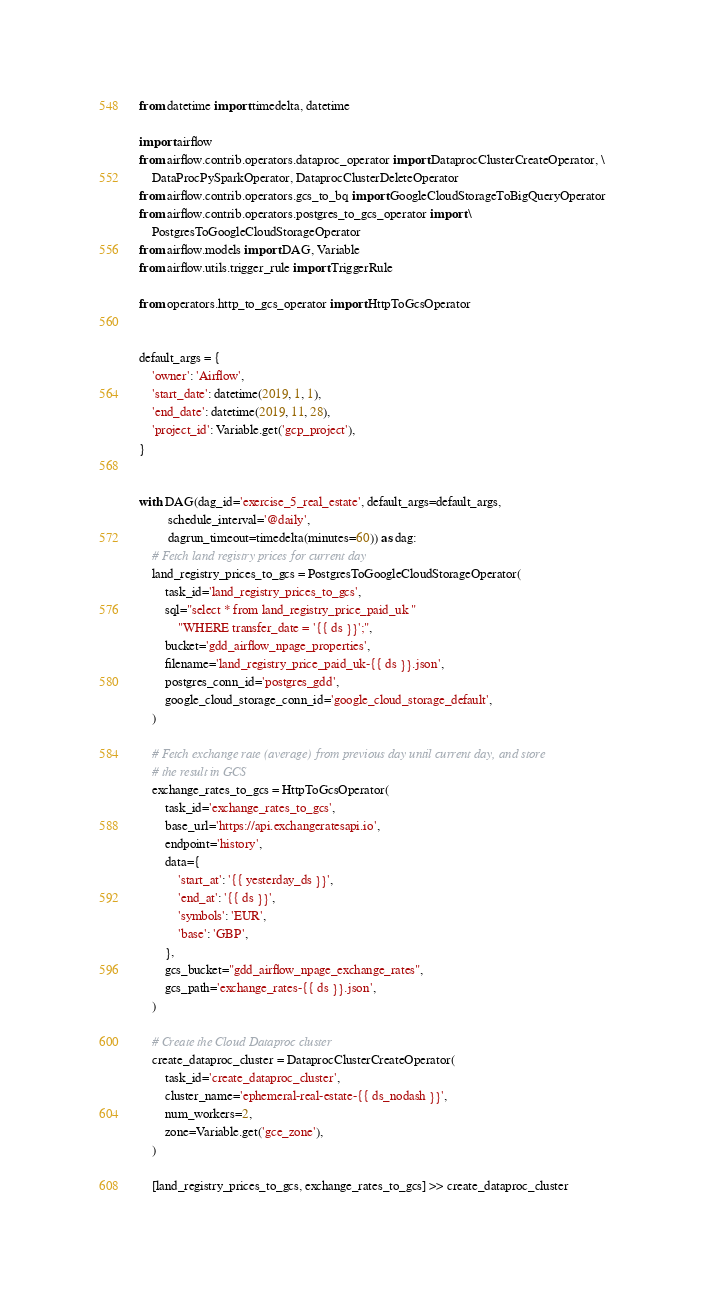Convert code to text. <code><loc_0><loc_0><loc_500><loc_500><_Python_>from datetime import timedelta, datetime

import airflow
from airflow.contrib.operators.dataproc_operator import DataprocClusterCreateOperator, \
    DataProcPySparkOperator, DataprocClusterDeleteOperator
from airflow.contrib.operators.gcs_to_bq import GoogleCloudStorageToBigQueryOperator
from airflow.contrib.operators.postgres_to_gcs_operator import \
    PostgresToGoogleCloudStorageOperator
from airflow.models import DAG, Variable
from airflow.utils.trigger_rule import TriggerRule

from operators.http_to_gcs_operator import HttpToGcsOperator


default_args = {
    'owner': 'Airflow',
    'start_date': datetime(2019, 1, 1),
    'end_date': datetime(2019, 11, 28),
    'project_id': Variable.get('gcp_project'),
}


with DAG(dag_id='exercise_5_real_estate', default_args=default_args,
         schedule_interval='@daily',
         dagrun_timeout=timedelta(minutes=60)) as dag:
    # Fetch land registry prices for current day
    land_registry_prices_to_gcs = PostgresToGoogleCloudStorageOperator(
        task_id='land_registry_prices_to_gcs',
        sql="select * from land_registry_price_paid_uk "
            "WHERE transfer_date = '{{ ds }}';",
        bucket='gdd_airflow_npage_properties',
        filename='land_registry_price_paid_uk-{{ ds }}.json',
        postgres_conn_id='postgres_gdd',
        google_cloud_storage_conn_id='google_cloud_storage_default',
    )

    # Fetch exchange rate (average) from previous day until current day, and store
    # the result in GCS
    exchange_rates_to_gcs = HttpToGcsOperator(
        task_id='exchange_rates_to_gcs',
        base_url='https://api.exchangeratesapi.io',
        endpoint='history',
        data={
            'start_at': '{{ yesterday_ds }}',
            'end_at': '{{ ds }}',
            'symbols': 'EUR',
            'base': 'GBP',
        },
        gcs_bucket="gdd_airflow_npage_exchange_rates",
        gcs_path='exchange_rates-{{ ds }}.json',
    )

    # Create the Cloud Dataproc cluster
    create_dataproc_cluster = DataprocClusterCreateOperator(
        task_id='create_dataproc_cluster',
        cluster_name='ephemeral-real-estate-{{ ds_nodash }}',
        num_workers=2,
        zone=Variable.get('gce_zone'),
    )

    [land_registry_prices_to_gcs, exchange_rates_to_gcs] >> create_dataproc_cluster
</code> 